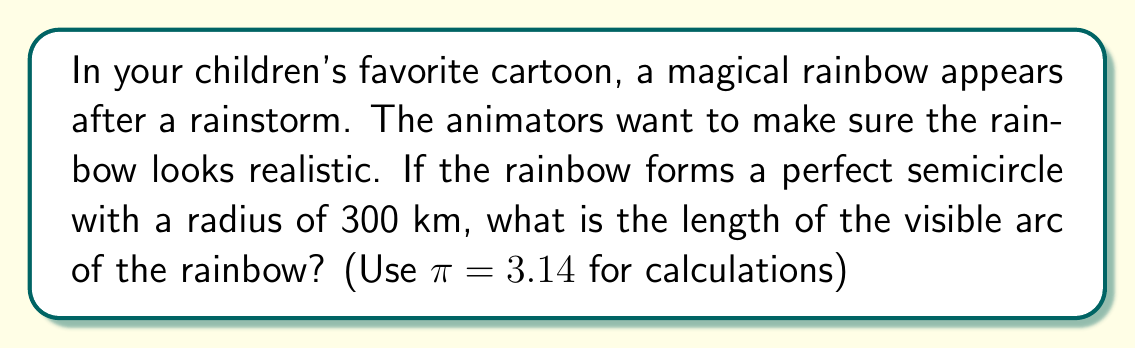Solve this math problem. Let's approach this step-by-step:

1) First, recall the formula for the arc length of a circle:

   $$s = r\theta$$

   Where $s$ is the arc length, $r$ is the radius, and $\theta$ is the central angle in radians.

2) We're given that the rainbow forms a semicircle. A semicircle has a central angle of $\pi$ radians or 180°.

3) We're also given that the radius of the rainbow is 300 km.

4) Now, let's substitute these values into our formula:

   $$s = 300 \cdot \pi$$

5) Using $\pi = 3.14$:

   $$s = 300 \cdot 3.14 = 942$$

6) Therefore, the length of the rainbow arc is 942 km.

[asy]
unitsize(0.5cm);
draw((-5,0)--(5,0));
draw(arc((0,0),5,0,180));
label("300 km", (2.5,2.5), NE);
label("Earth's surface", (0,-0.5), S);
[/asy]

This diagram represents the rainbow as a semicircle above the Earth's surface (simplified, not to scale).
Answer: The length of the visible arc of the rainbow is 942 km. 